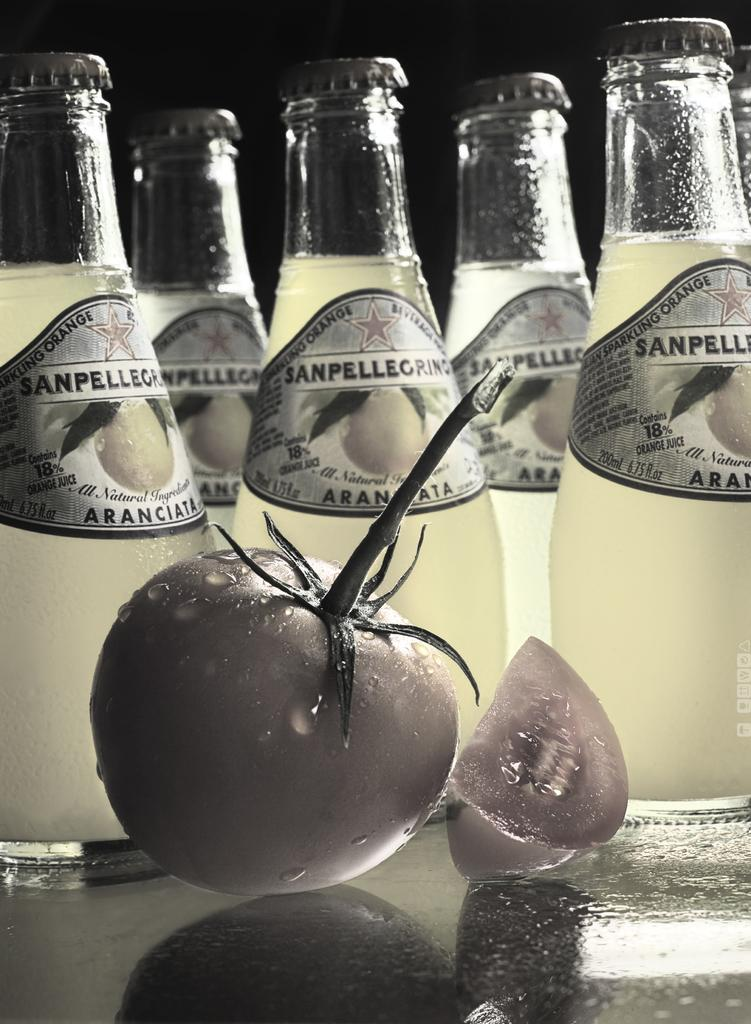What objects are present in the image that are related to beverages? There is a group of drink bottles in the image. What type of fruit can be seen in the image? There is a tomato in the image. What type of clock is visible in the image? There is no clock present in the image. What type of brass object can be seen in the image? There is no brass object present in the image. 